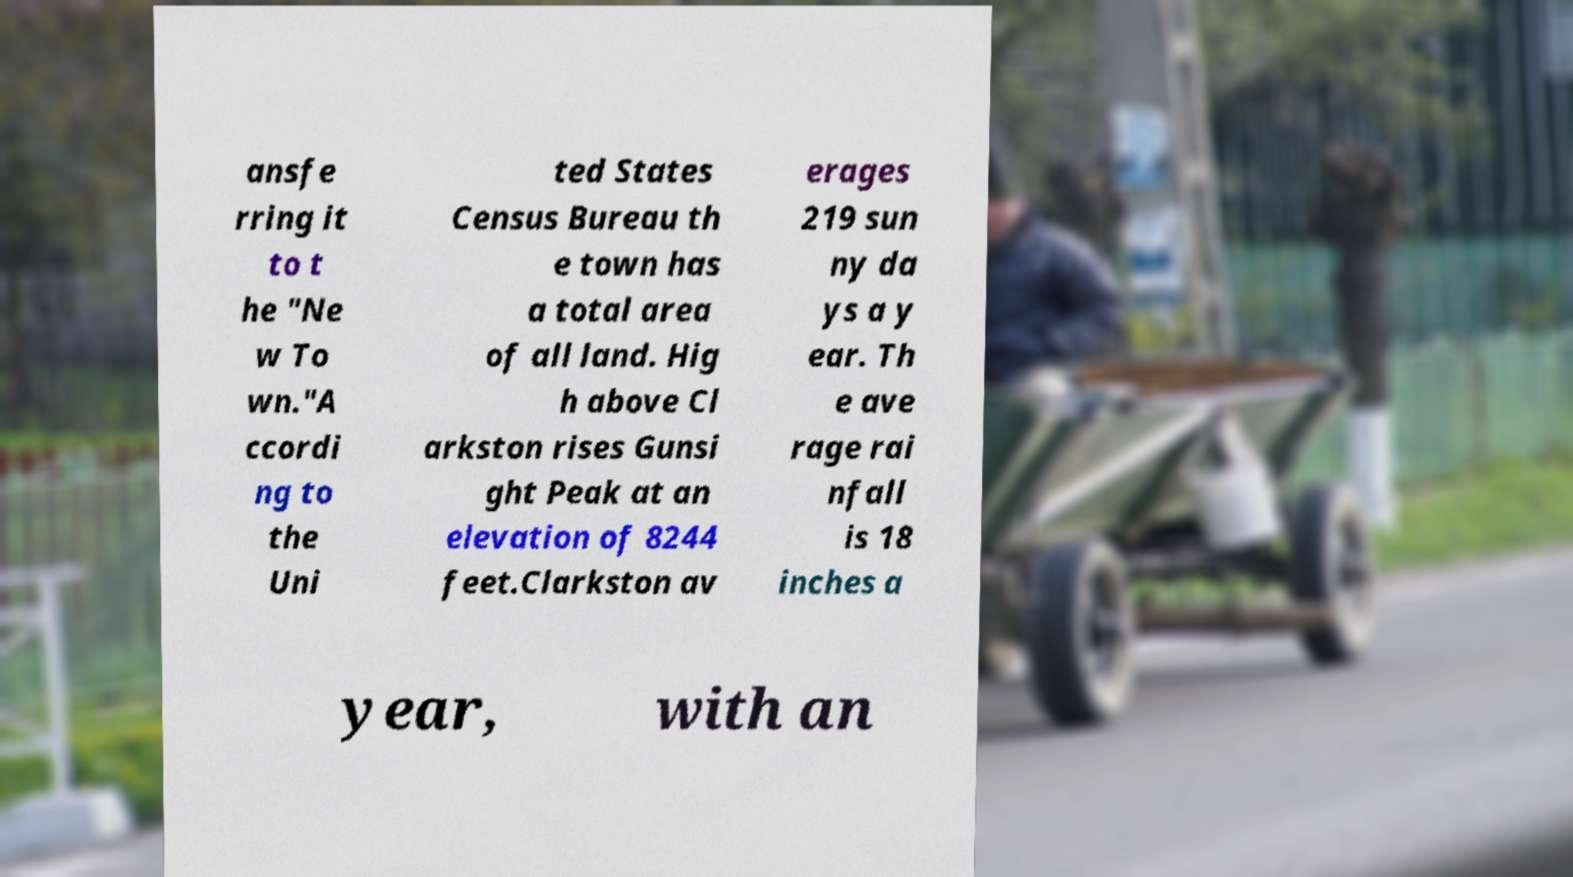Please read and relay the text visible in this image. What does it say? ansfe rring it to t he "Ne w To wn."A ccordi ng to the Uni ted States Census Bureau th e town has a total area of all land. Hig h above Cl arkston rises Gunsi ght Peak at an elevation of 8244 feet.Clarkston av erages 219 sun ny da ys a y ear. Th e ave rage rai nfall is 18 inches a year, with an 